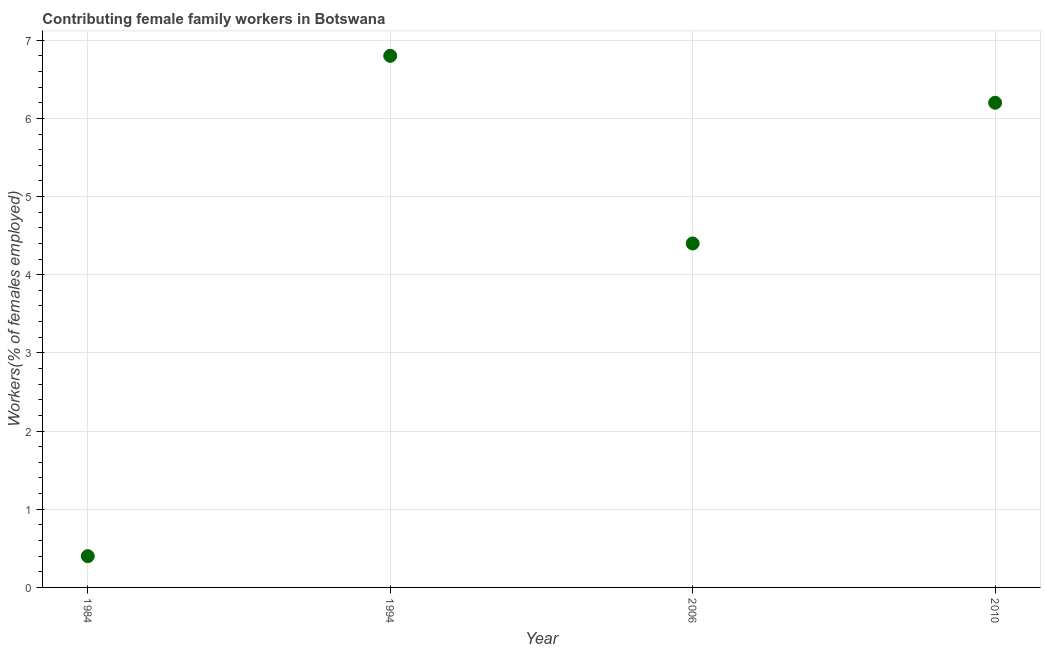What is the contributing female family workers in 1994?
Make the answer very short. 6.8. Across all years, what is the maximum contributing female family workers?
Make the answer very short. 6.8. Across all years, what is the minimum contributing female family workers?
Provide a short and direct response. 0.4. What is the sum of the contributing female family workers?
Provide a short and direct response. 17.8. What is the difference between the contributing female family workers in 1984 and 2006?
Ensure brevity in your answer.  -4. What is the average contributing female family workers per year?
Ensure brevity in your answer.  4.45. What is the median contributing female family workers?
Make the answer very short. 5.3. What is the ratio of the contributing female family workers in 1984 to that in 2006?
Make the answer very short. 0.09. Is the contributing female family workers in 1984 less than that in 2010?
Offer a terse response. Yes. What is the difference between the highest and the second highest contributing female family workers?
Your response must be concise. 0.6. Is the sum of the contributing female family workers in 1984 and 2006 greater than the maximum contributing female family workers across all years?
Provide a succinct answer. No. What is the difference between the highest and the lowest contributing female family workers?
Make the answer very short. 6.4. In how many years, is the contributing female family workers greater than the average contributing female family workers taken over all years?
Make the answer very short. 2. Does the contributing female family workers monotonically increase over the years?
Keep it short and to the point. No. Does the graph contain grids?
Ensure brevity in your answer.  Yes. What is the title of the graph?
Ensure brevity in your answer.  Contributing female family workers in Botswana. What is the label or title of the Y-axis?
Keep it short and to the point. Workers(% of females employed). What is the Workers(% of females employed) in 1984?
Make the answer very short. 0.4. What is the Workers(% of females employed) in 1994?
Ensure brevity in your answer.  6.8. What is the Workers(% of females employed) in 2006?
Make the answer very short. 4.4. What is the Workers(% of females employed) in 2010?
Provide a short and direct response. 6.2. What is the difference between the Workers(% of females employed) in 1984 and 1994?
Your answer should be compact. -6.4. What is the difference between the Workers(% of females employed) in 1984 and 2006?
Ensure brevity in your answer.  -4. What is the difference between the Workers(% of females employed) in 1984 and 2010?
Offer a terse response. -5.8. What is the difference between the Workers(% of females employed) in 1994 and 2006?
Give a very brief answer. 2.4. What is the difference between the Workers(% of females employed) in 2006 and 2010?
Give a very brief answer. -1.8. What is the ratio of the Workers(% of females employed) in 1984 to that in 1994?
Your answer should be very brief. 0.06. What is the ratio of the Workers(% of females employed) in 1984 to that in 2006?
Ensure brevity in your answer.  0.09. What is the ratio of the Workers(% of females employed) in 1984 to that in 2010?
Offer a very short reply. 0.07. What is the ratio of the Workers(% of females employed) in 1994 to that in 2006?
Make the answer very short. 1.54. What is the ratio of the Workers(% of females employed) in 1994 to that in 2010?
Your answer should be compact. 1.1. What is the ratio of the Workers(% of females employed) in 2006 to that in 2010?
Your answer should be compact. 0.71. 